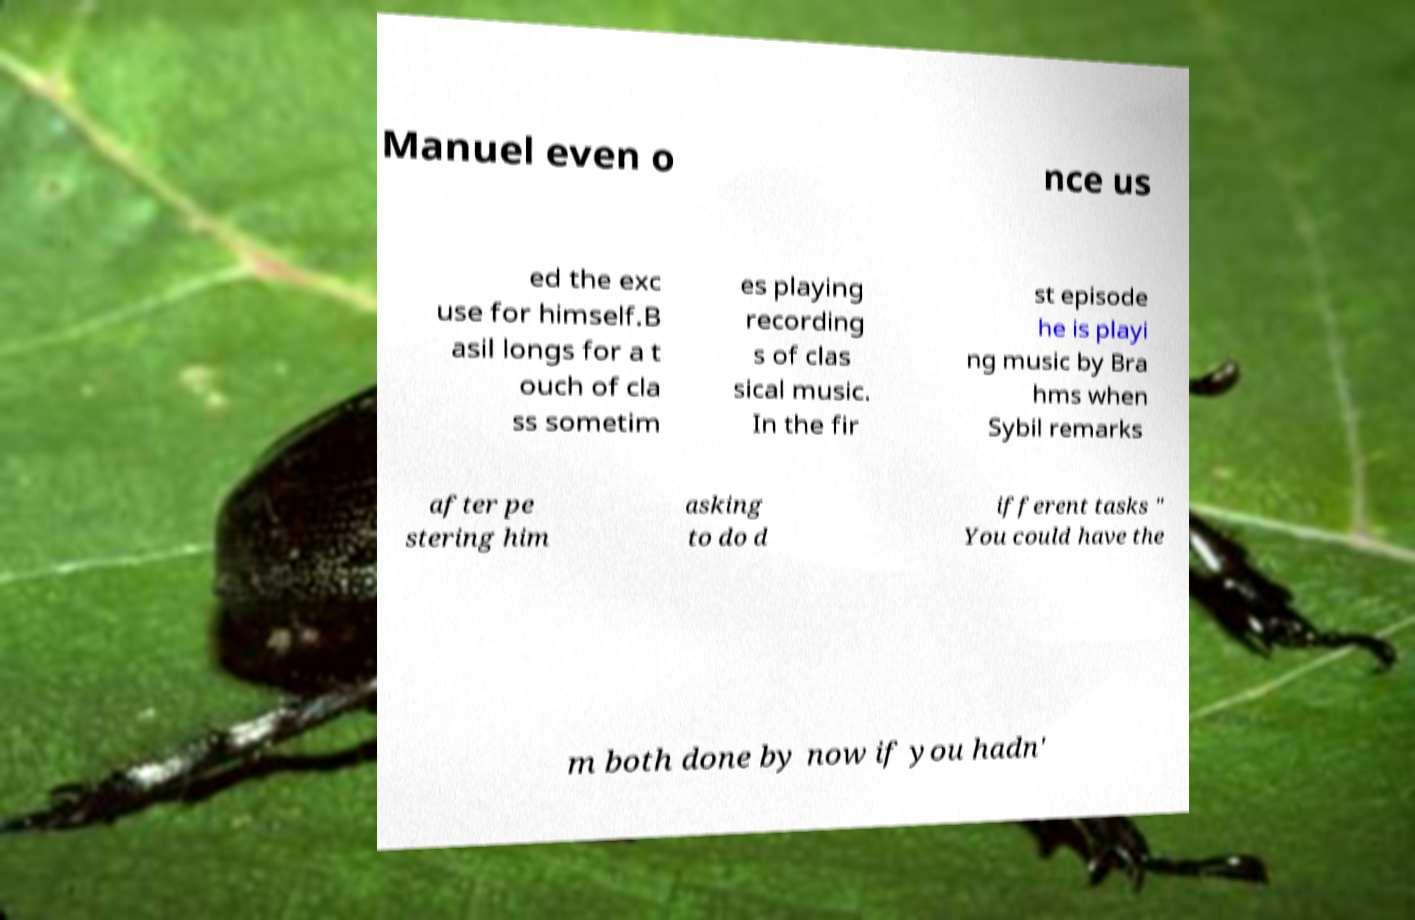Can you accurately transcribe the text from the provided image for me? Manuel even o nce us ed the exc use for himself.B asil longs for a t ouch of cla ss sometim es playing recording s of clas sical music. In the fir st episode he is playi ng music by Bra hms when Sybil remarks after pe stering him asking to do d ifferent tasks " You could have the m both done by now if you hadn' 